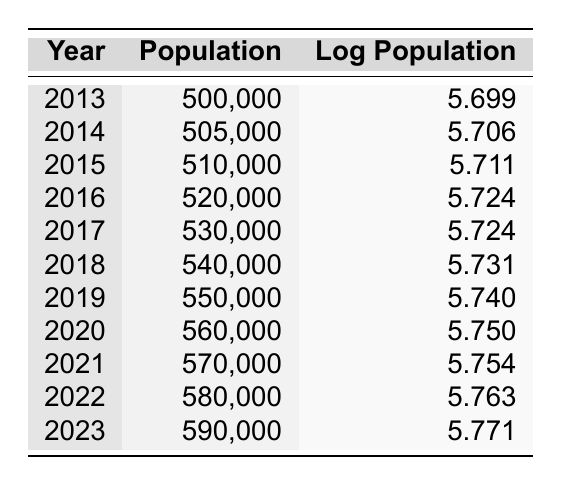What was the population in 2015? The table shows that the population for the year 2015 is specifically listed as 510,000.
Answer: 510,000 In which year did the city first exceed a population of 550,000? By examining the table, we see that the population first exceeds 550,000 in 2019, as the population for 2018 is 540,000 and jumps to 550,000 in 2019.
Answer: 2019 How much did the population grow from 2013 to 2023? The population in 2013 was 500,000, and in 2023 it is 590,000. Therefore, the growth is 590,000 - 500,000 = 90,000.
Answer: 90,000 Is it true that the log population value increased from 2014 to 2016? In the table, the log population in 2014 is 5.706, and in 2016 it is 5.724. Since 5.724 is greater than 5.706, the statement is true.
Answer: Yes What was the average population from 2013 to 2022? To calculate the average, we sum the populations from 2013 (500,000) to 2022 (580,000), which gives us 500,000 + 505,000 + 510,000 + 520,000 + 530,000 + 540,000 + 550,000 + 560,000 + 570,000 + 580,000 = 5,325,000. There are 10 years, so the average is 5,325,000 / 10 = 532,500.
Answer: 532,500 How much did the log population increase from 2017 to 2023? The log population for 2017 is 5.724 and for 2023 it is 5.771. To find the increase, we subtract: 5.771 - 5.724 = 0.047.
Answer: 0.047 